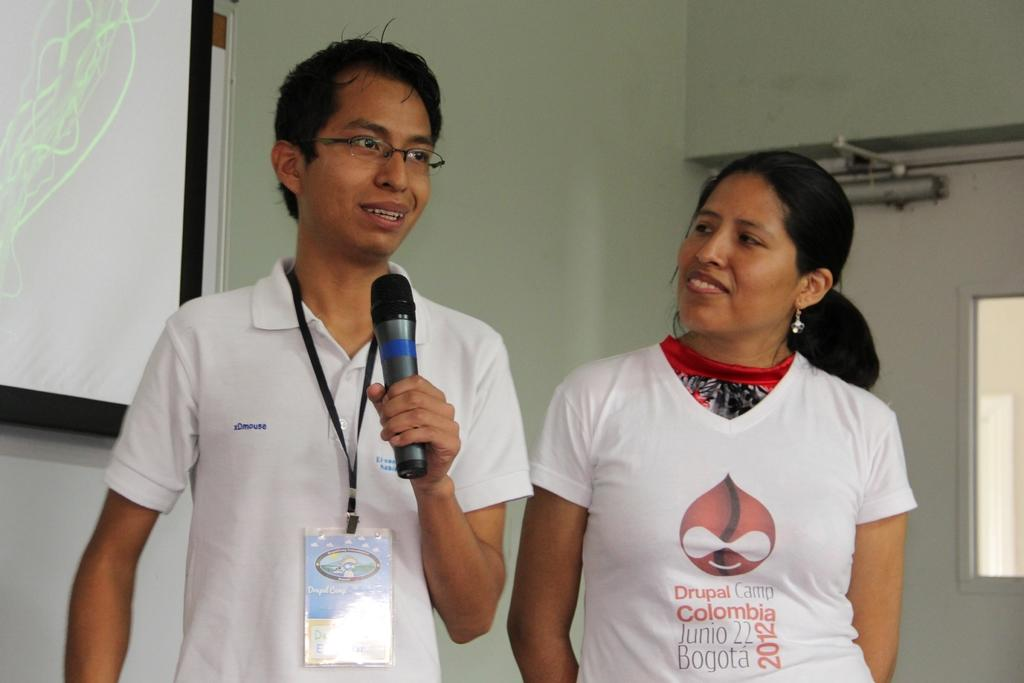How many people are present in the image? There are two people, a man and a woman, present in the image. What is the man holding in the image? The man is holding a mic. What can be seen in the background of the image? There is a wall and a window visible in the background of the image. What device is used for displaying images or videos in the image? There is a projector visible in the image. How many apples are being smashed on the property in the image? There are no apples or property visible in the image. 